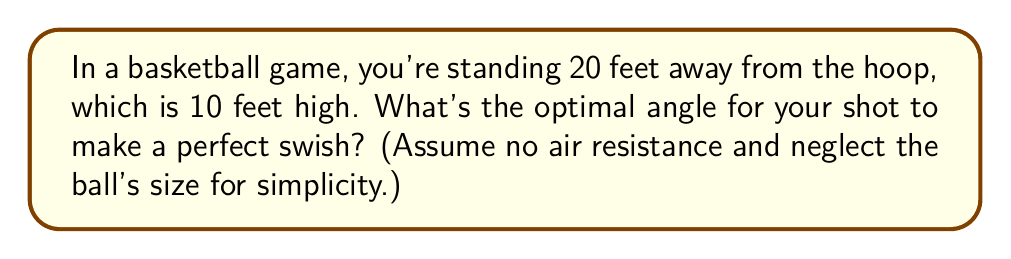Teach me how to tackle this problem. Let's break this down into simple steps:

1) First, we need to visualize the problem. We can think of this as a right triangle:
   - The horizontal distance to the hoop is 20 feet (base of the triangle)
   - The height of the hoop is 10 feet (height of the triangle)
   - The path of the ball is the hypotenuse

2) We're looking for the angle between the ground and the path of the ball. Let's call this angle θ.

3) In trigonometry, we can find this angle using the tangent function:

   $$ \tan(\theta) = \frac{\text{opposite}}{\text{adjacent}} = \frac{\text{height of hoop}}{\text{distance to hoop}} $$

4) Plugging in our values:

   $$ \tan(\theta) = \frac{10}{20} = \frac{1}{2} $$

5) To find θ, we need to use the inverse tangent (arctan or tan^(-1)):

   $$ \theta = \tan^{-1}(\frac{1}{2}) $$

6) Using a calculator or trigonometric tables, we can find that:

   $$ \theta \approx 26.57° $$

Therefore, the optimal angle for the shot is approximately 26.57 degrees.

[asy]
import geometry;

size(200);
draw((0,0)--(20,0)--(20,10)--(0,0),Arrow);
draw((0,0)--(20,10),Arrow);
label("20 ft", (10,0), S);
label("10 ft", (20,5), E);
label("θ", (2,1), NW);
dot((0,0));
dot((20,10));
[/asy]
Answer: $26.57°$ 